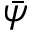Convert formula to latex. <formula><loc_0><loc_0><loc_500><loc_500>\bar { \psi }</formula> 